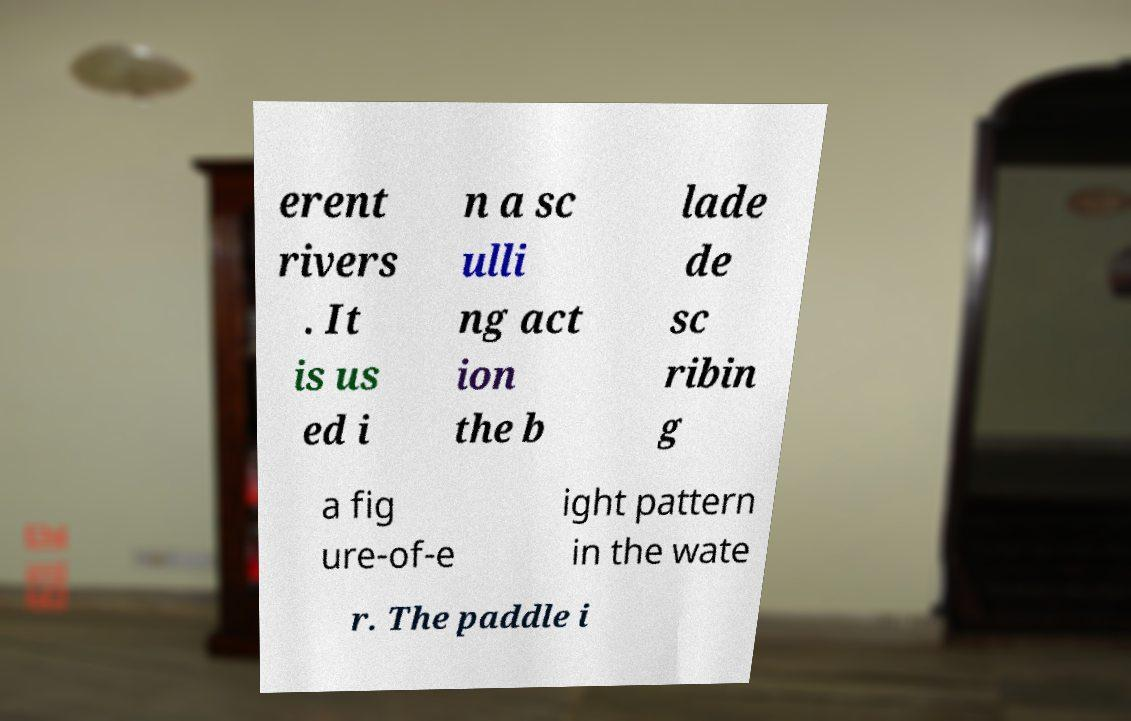Please identify and transcribe the text found in this image. erent rivers . It is us ed i n a sc ulli ng act ion the b lade de sc ribin g a fig ure-of-e ight pattern in the wate r. The paddle i 